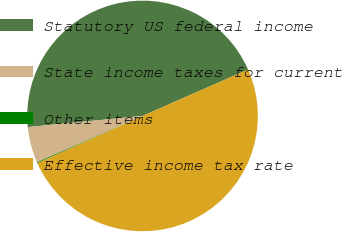<chart> <loc_0><loc_0><loc_500><loc_500><pie_chart><fcel>Statutory US federal income<fcel>State income taxes for current<fcel>Other items<fcel>Effective income tax rate<nl><fcel>44.95%<fcel>5.05%<fcel>0.13%<fcel>49.87%<nl></chart> 